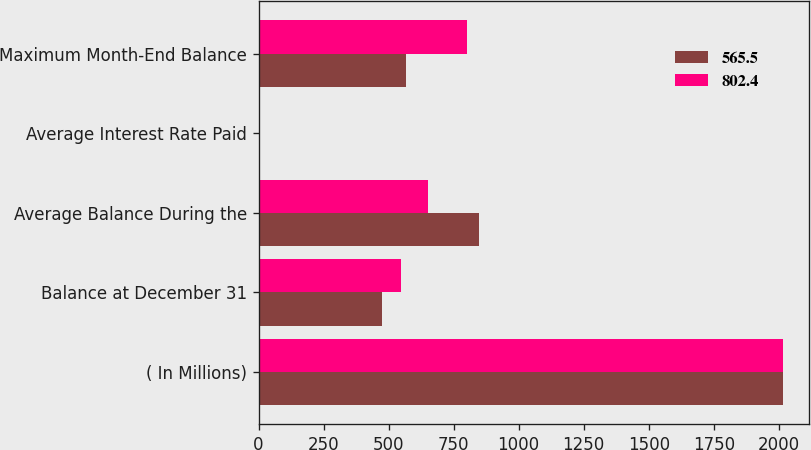Convert chart to OTSL. <chart><loc_0><loc_0><loc_500><loc_500><stacked_bar_chart><ecel><fcel>( In Millions)<fcel>Balance at December 31<fcel>Average Balance During the<fcel>Average Interest Rate Paid<fcel>Maximum Month-End Balance<nl><fcel>565.5<fcel>2016<fcel>473.7<fcel>847.1<fcel>0.27<fcel>565.5<nl><fcel>802.4<fcel>2015<fcel>546.6<fcel>649.5<fcel>0.05<fcel>802.4<nl></chart> 